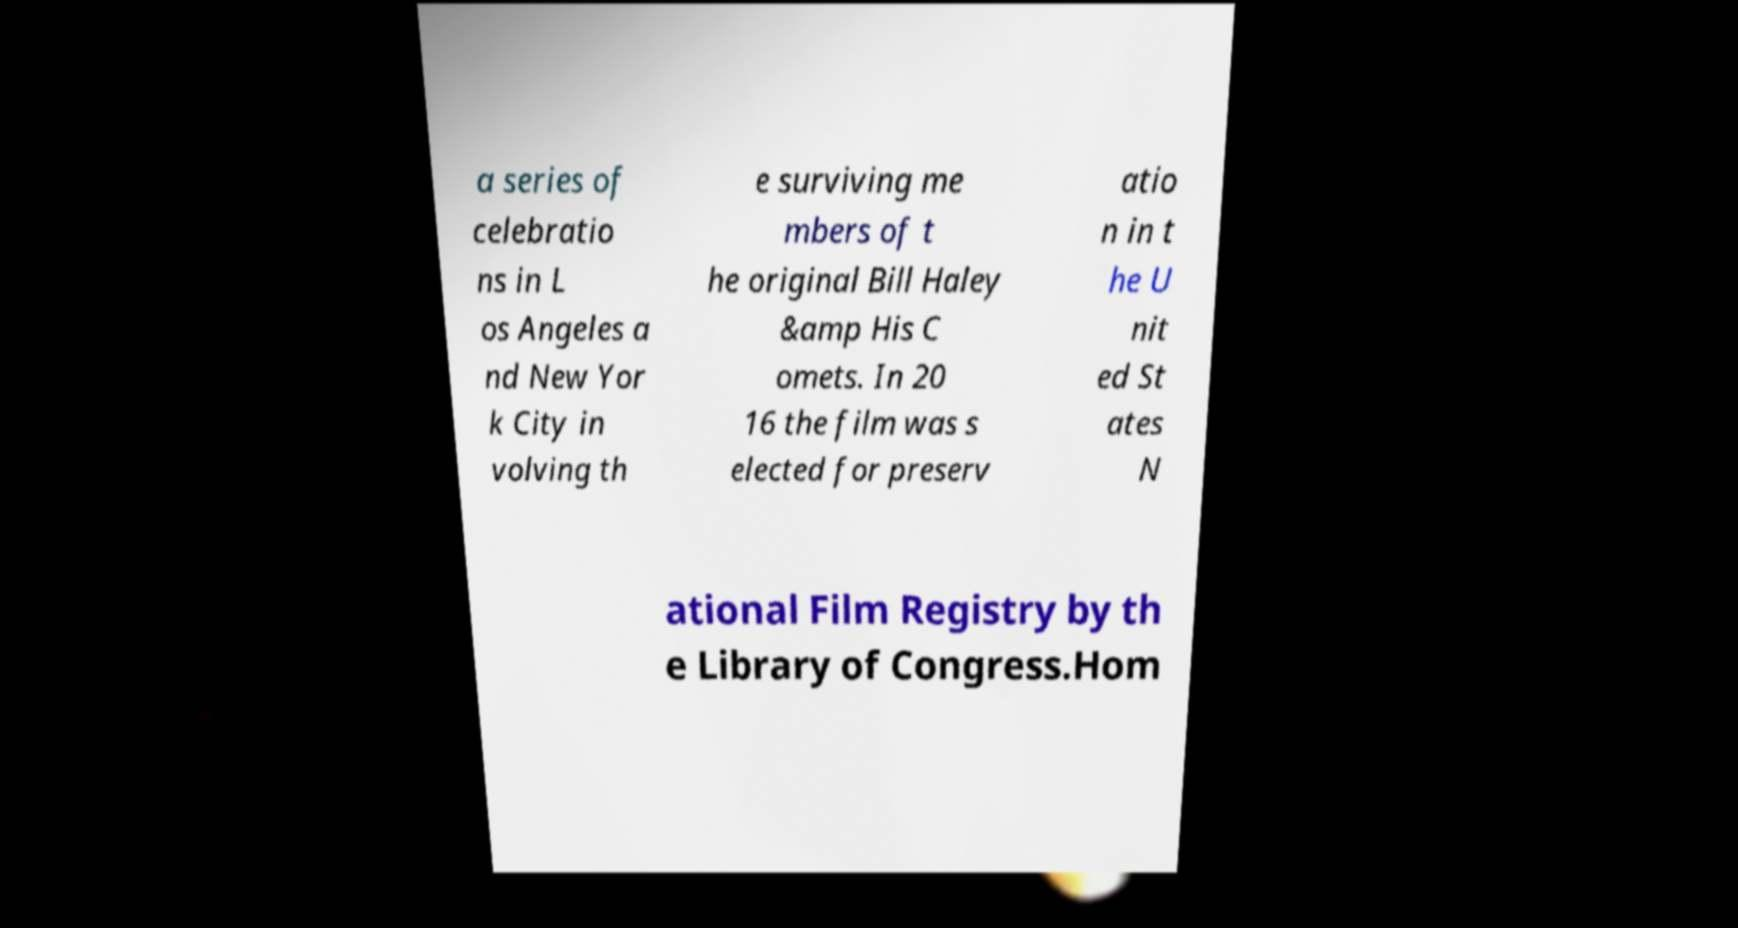I need the written content from this picture converted into text. Can you do that? a series of celebratio ns in L os Angeles a nd New Yor k City in volving th e surviving me mbers of t he original Bill Haley &amp His C omets. In 20 16 the film was s elected for preserv atio n in t he U nit ed St ates N ational Film Registry by th e Library of Congress.Hom 